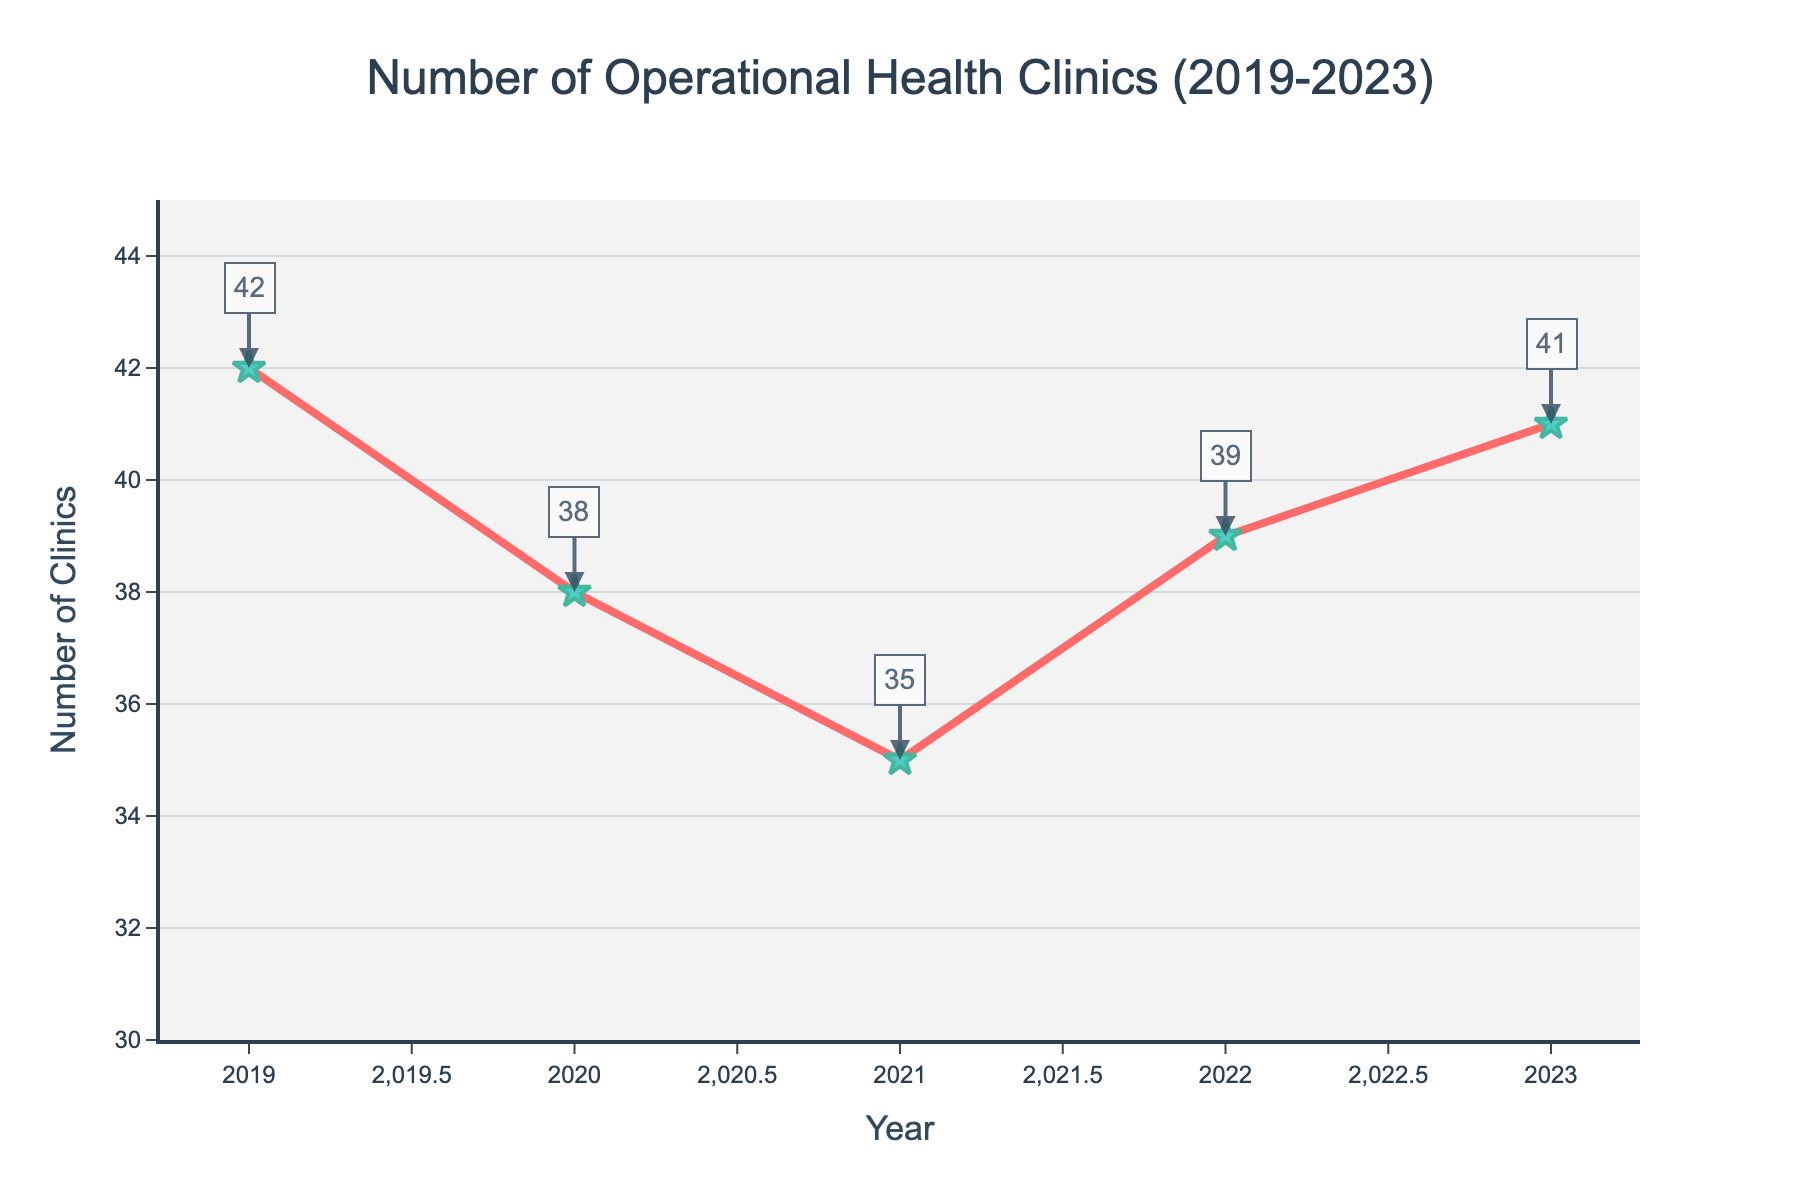What's the highest number of operational health clinics recorded? Look for the peak value of the y-axis on the line chart and read the corresponding annotation. The highest number is in 2019 with 42 clinics.
Answer: 42 What's the lowest number of operational health clinics observed? Check the lowest point of the y-axis on the line chart and the annotation next to the point. The lowest number is in 2021 with 35 clinics.
Answer: 35 By how much did the number of operational health clinics change from 2020 to 2022? Refer to the values of health clinics for 2020 and 2022, which are 38 and 39, respectively. Calculate the difference 39 - 38 = 1.
Answer: 1 Which year showed the largest decrease in the number of clinics compared to the previous year? Compare the year-by-year differences: 2019 to 2020 (-4), 2020 to 2021 (-3), 2021 to 2022 (+4), and 2022 to 2023 (+2). The largest decrease is from 2019 to 2020.
Answer: 2020 What’s the average number of operational health clinics over these five years? Calculate the sum: 42 + 38 + 35 + 39 + 41 = 195. Divide the sum by 5, i.e., 195 ÷ 5 = 39.
Answer: 39 Which year shows a number of clinics closest to the five-year average? The five-year average is 39. Compare each year’s figures to 39: 2019 (42, difference 3), 2020 (38, difference 1), 2021 (35, difference 4), 2022 (39, difference 0), 2023 (41, difference 2). The closest is 2022 with 39 clinics.
Answer: 2022 Between which two consecutive years did the number of health clinics increase the most? Compare the increases: 2020 to 2021 (-3), 2021 to 2022 (+4), and 2022 to 2023 (+2). The largest increase is between 2021 and 2022.
Answer: 2021 to 2022 Are there more clinics in 2023 compared to 2020? Compare the values for 2023 (41) and 2020 (38). There are more clinics in 2023.
Answer: Yes What’s the total change in the number of clinics from 2019 to 2023? Compare the figures for 2019 (42) and 2023 (41). Calculate the difference 41 - 42 = -1, indicating a decrease by 1.
Answer: -1 